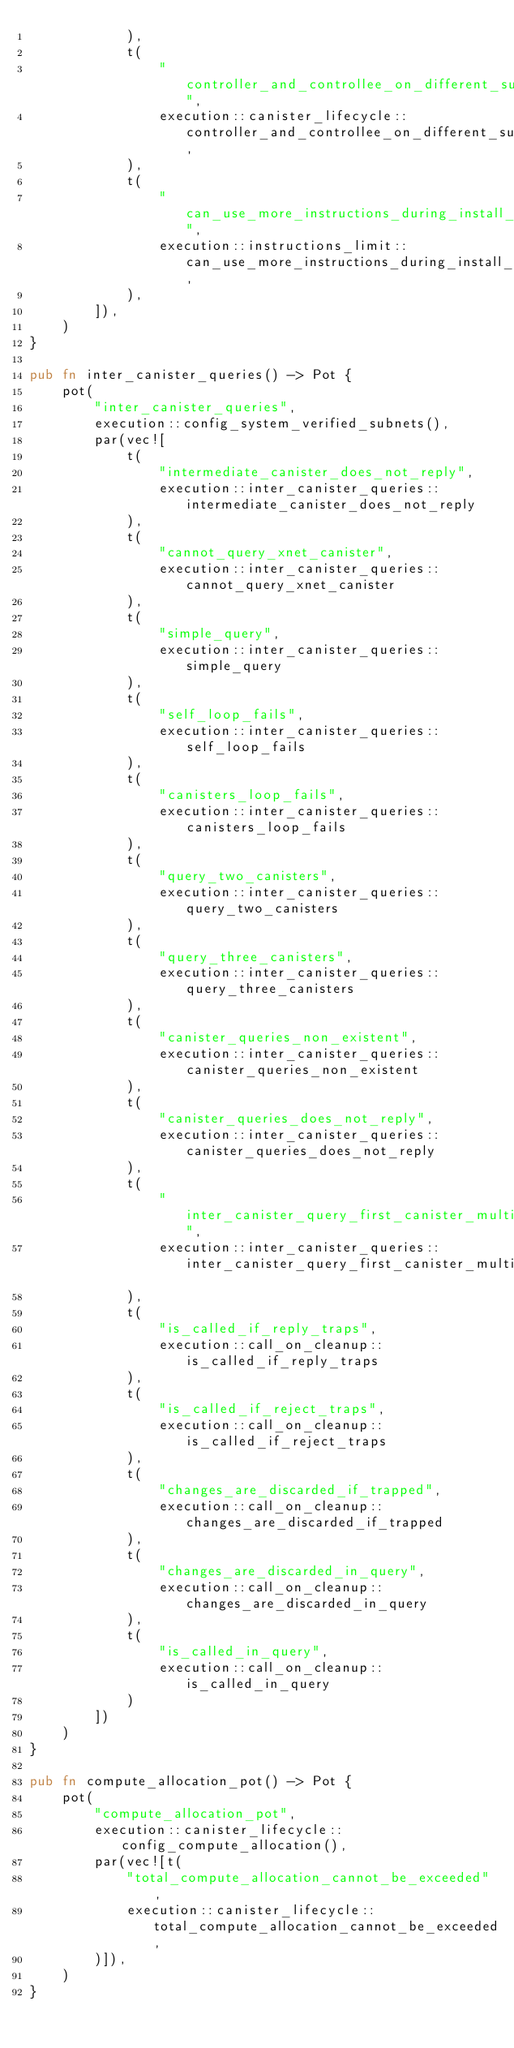<code> <loc_0><loc_0><loc_500><loc_500><_Rust_>            ),
            t(
                "controller_and_controllee_on_different_subnets",
                execution::canister_lifecycle::controller_and_controllee_on_different_subnets,
            ),
            t(
                "can_use_more_instructions_during_install_code",
                execution::instructions_limit::can_use_more_instructions_during_install_code,
            ),
        ]),
    )
}

pub fn inter_canister_queries() -> Pot {
    pot(
        "inter_canister_queries",
        execution::config_system_verified_subnets(),
        par(vec![
            t(
                "intermediate_canister_does_not_reply",
                execution::inter_canister_queries::intermediate_canister_does_not_reply
            ),
            t(
                "cannot_query_xnet_canister",
                execution::inter_canister_queries::cannot_query_xnet_canister
            ),
            t(
                "simple_query",
                execution::inter_canister_queries::simple_query
            ),
            t(
                "self_loop_fails",
                execution::inter_canister_queries::self_loop_fails
            ),
            t(
                "canisters_loop_fails",
                execution::inter_canister_queries::canisters_loop_fails
            ),
            t(
                "query_two_canisters",
                execution::inter_canister_queries::query_two_canisters
            ),
            t(
                "query_three_canisters",
                execution::inter_canister_queries::query_three_canisters
            ),
            t(
                "canister_queries_non_existent",
                execution::inter_canister_queries::canister_queries_non_existent
            ),
            t(
                "canister_queries_does_not_reply",
                execution::inter_canister_queries::canister_queries_does_not_reply
            ),
            t(
                "inter_canister_query_first_canister_multiple_request",
                execution::inter_canister_queries::inter_canister_query_first_canister_multiple_request
            ),
            t(
                "is_called_if_reply_traps",
                execution::call_on_cleanup::is_called_if_reply_traps
            ),
            t(
                "is_called_if_reject_traps",
                execution::call_on_cleanup::is_called_if_reject_traps
            ),
            t(
                "changes_are_discarded_if_trapped",
                execution::call_on_cleanup::changes_are_discarded_if_trapped
            ),
            t(
                "changes_are_discarded_in_query",
                execution::call_on_cleanup::changes_are_discarded_in_query
            ),
            t(
                "is_called_in_query",
                execution::call_on_cleanup::is_called_in_query
            )
        ])
    )
}

pub fn compute_allocation_pot() -> Pot {
    pot(
        "compute_allocation_pot",
        execution::canister_lifecycle::config_compute_allocation(),
        par(vec![t(
            "total_compute_allocation_cannot_be_exceeded",
            execution::canister_lifecycle::total_compute_allocation_cannot_be_exceeded,
        )]),
    )
}
</code> 